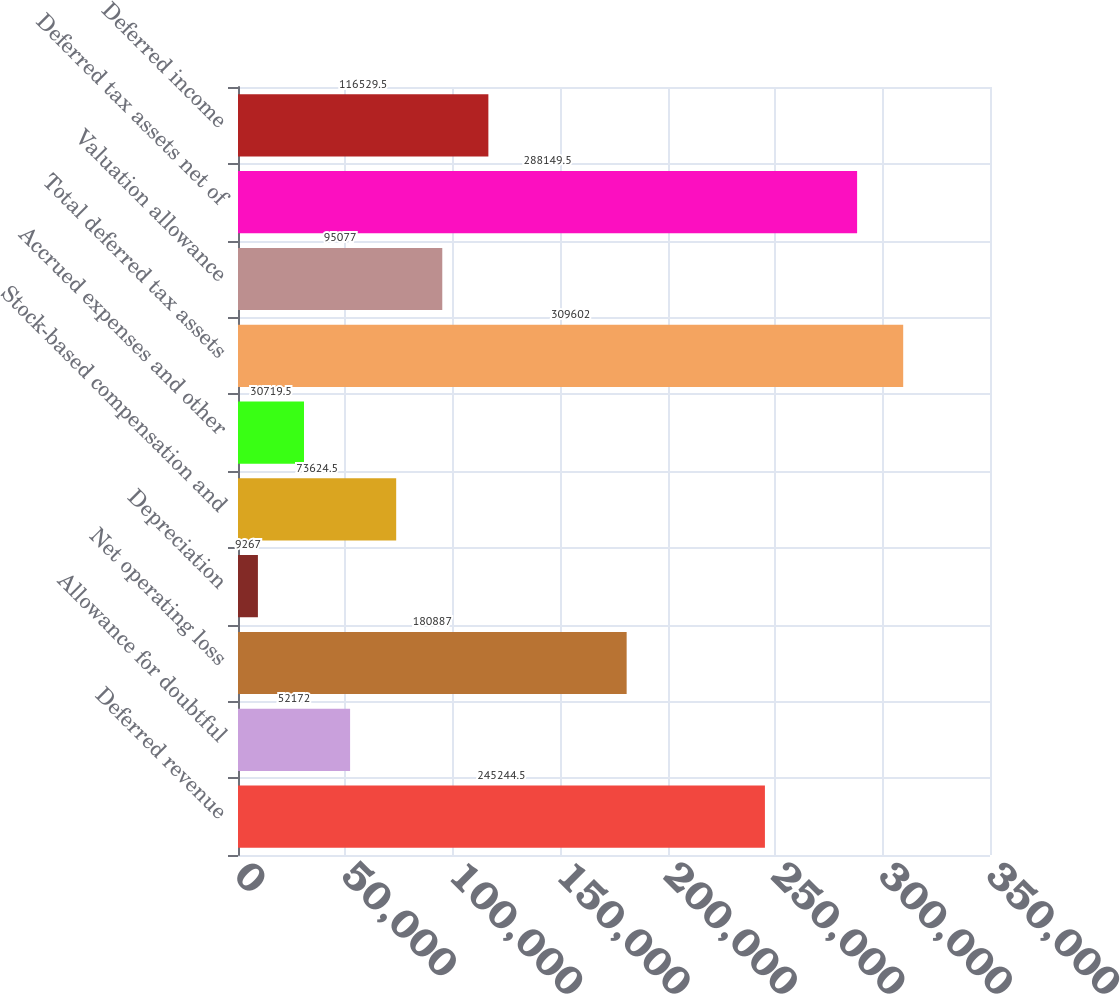Convert chart to OTSL. <chart><loc_0><loc_0><loc_500><loc_500><bar_chart><fcel>Deferred revenue<fcel>Allowance for doubtful<fcel>Net operating loss<fcel>Depreciation<fcel>Stock-based compensation and<fcel>Accrued expenses and other<fcel>Total deferred tax assets<fcel>Valuation allowance<fcel>Deferred tax assets net of<fcel>Deferred income<nl><fcel>245244<fcel>52172<fcel>180887<fcel>9267<fcel>73624.5<fcel>30719.5<fcel>309602<fcel>95077<fcel>288150<fcel>116530<nl></chart> 